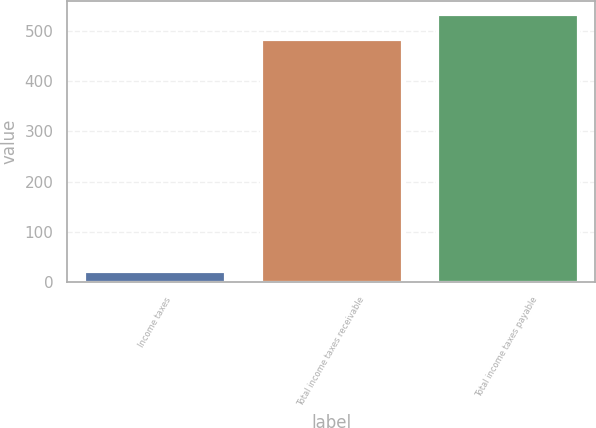Convert chart to OTSL. <chart><loc_0><loc_0><loc_500><loc_500><bar_chart><fcel>Income taxes<fcel>Total income taxes receivable<fcel>Total income taxes payable<nl><fcel>22<fcel>483.7<fcel>533.4<nl></chart> 